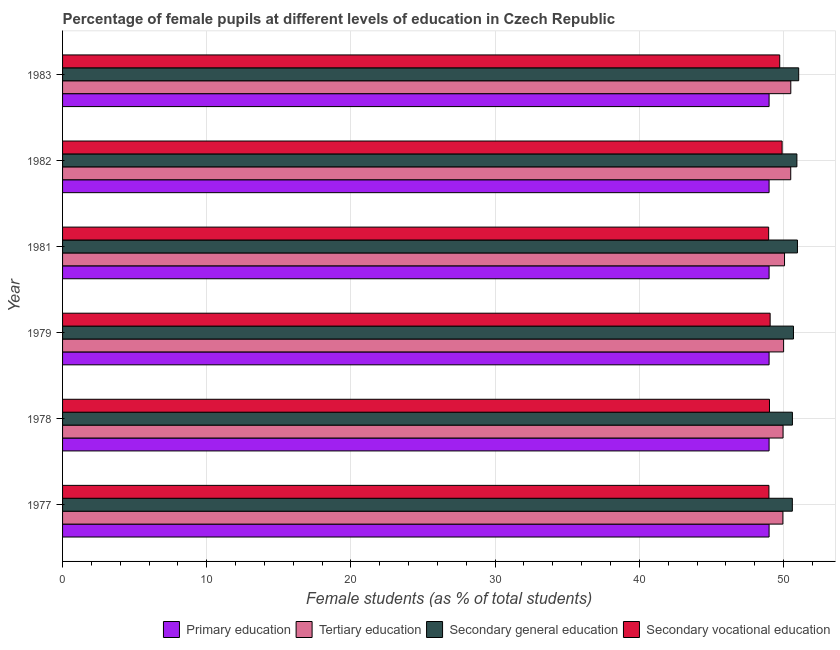How many different coloured bars are there?
Your response must be concise. 4. Are the number of bars on each tick of the Y-axis equal?
Keep it short and to the point. Yes. What is the percentage of female students in secondary education in 1978?
Give a very brief answer. 50.62. Across all years, what is the maximum percentage of female students in primary education?
Make the answer very short. 49. Across all years, what is the minimum percentage of female students in secondary vocational education?
Provide a succinct answer. 48.97. In which year was the percentage of female students in primary education minimum?
Ensure brevity in your answer.  1979. What is the total percentage of female students in tertiary education in the graph?
Ensure brevity in your answer.  301.01. What is the difference between the percentage of female students in tertiary education in 1979 and the percentage of female students in primary education in 1978?
Ensure brevity in your answer.  1.01. What is the average percentage of female students in secondary vocational education per year?
Ensure brevity in your answer.  49.28. In the year 1981, what is the difference between the percentage of female students in tertiary education and percentage of female students in primary education?
Offer a terse response. 1.07. In how many years, is the percentage of female students in secondary vocational education greater than 36 %?
Give a very brief answer. 6. What is the ratio of the percentage of female students in tertiary education in 1977 to that in 1983?
Make the answer very short. 0.99. What is the difference between the highest and the second highest percentage of female students in secondary education?
Your answer should be very brief. 0.09. What is the difference between the highest and the lowest percentage of female students in primary education?
Offer a terse response. 0. In how many years, is the percentage of female students in primary education greater than the average percentage of female students in primary education taken over all years?
Make the answer very short. 3. Is the sum of the percentage of female students in secondary vocational education in 1977 and 1981 greater than the maximum percentage of female students in tertiary education across all years?
Keep it short and to the point. Yes. What does the 2nd bar from the top in 1982 represents?
Give a very brief answer. Secondary general education. What does the 2nd bar from the bottom in 1977 represents?
Give a very brief answer. Tertiary education. How many years are there in the graph?
Offer a very short reply. 6. What is the difference between two consecutive major ticks on the X-axis?
Your answer should be very brief. 10. Does the graph contain any zero values?
Keep it short and to the point. No. Where does the legend appear in the graph?
Provide a short and direct response. Bottom right. What is the title of the graph?
Ensure brevity in your answer.  Percentage of female pupils at different levels of education in Czech Republic. What is the label or title of the X-axis?
Ensure brevity in your answer.  Female students (as % of total students). What is the Female students (as % of total students) of Primary education in 1977?
Give a very brief answer. 49. What is the Female students (as % of total students) in Tertiary education in 1977?
Provide a succinct answer. 49.96. What is the Female students (as % of total students) in Secondary general education in 1977?
Provide a succinct answer. 50.61. What is the Female students (as % of total students) in Secondary vocational education in 1977?
Make the answer very short. 48.99. What is the Female students (as % of total students) in Primary education in 1978?
Give a very brief answer. 49. What is the Female students (as % of total students) of Tertiary education in 1978?
Ensure brevity in your answer.  49.97. What is the Female students (as % of total students) in Secondary general education in 1978?
Provide a succinct answer. 50.62. What is the Female students (as % of total students) of Secondary vocational education in 1978?
Offer a terse response. 49.03. What is the Female students (as % of total students) of Primary education in 1979?
Provide a succinct answer. 49. What is the Female students (as % of total students) in Tertiary education in 1979?
Make the answer very short. 50.01. What is the Female students (as % of total students) of Secondary general education in 1979?
Your answer should be compact. 50.69. What is the Female students (as % of total students) of Secondary vocational education in 1979?
Keep it short and to the point. 49.07. What is the Female students (as % of total students) of Primary education in 1981?
Offer a very short reply. 49. What is the Female students (as % of total students) in Tertiary education in 1981?
Offer a terse response. 50.07. What is the Female students (as % of total students) in Secondary general education in 1981?
Your answer should be compact. 50.97. What is the Female students (as % of total students) in Secondary vocational education in 1981?
Offer a terse response. 48.97. What is the Female students (as % of total students) in Primary education in 1982?
Provide a succinct answer. 49. What is the Female students (as % of total students) in Tertiary education in 1982?
Provide a short and direct response. 50.5. What is the Female students (as % of total students) of Secondary general education in 1982?
Provide a short and direct response. 50.93. What is the Female students (as % of total students) in Secondary vocational education in 1982?
Your answer should be very brief. 49.9. What is the Female students (as % of total students) of Tertiary education in 1983?
Provide a succinct answer. 50.51. What is the Female students (as % of total students) of Secondary general education in 1983?
Make the answer very short. 51.05. What is the Female students (as % of total students) of Secondary vocational education in 1983?
Your response must be concise. 49.74. Across all years, what is the maximum Female students (as % of total students) in Primary education?
Your answer should be very brief. 49. Across all years, what is the maximum Female students (as % of total students) of Tertiary education?
Make the answer very short. 50.51. Across all years, what is the maximum Female students (as % of total students) in Secondary general education?
Provide a short and direct response. 51.05. Across all years, what is the maximum Female students (as % of total students) of Secondary vocational education?
Give a very brief answer. 49.9. Across all years, what is the minimum Female students (as % of total students) of Primary education?
Offer a very short reply. 49. Across all years, what is the minimum Female students (as % of total students) in Tertiary education?
Provide a succinct answer. 49.96. Across all years, what is the minimum Female students (as % of total students) of Secondary general education?
Ensure brevity in your answer.  50.61. Across all years, what is the minimum Female students (as % of total students) in Secondary vocational education?
Provide a short and direct response. 48.97. What is the total Female students (as % of total students) in Primary education in the graph?
Provide a short and direct response. 294. What is the total Female students (as % of total students) in Tertiary education in the graph?
Keep it short and to the point. 301.01. What is the total Female students (as % of total students) of Secondary general education in the graph?
Make the answer very short. 304.87. What is the total Female students (as % of total students) of Secondary vocational education in the graph?
Provide a succinct answer. 295.7. What is the difference between the Female students (as % of total students) of Primary education in 1977 and that in 1978?
Your response must be concise. 0. What is the difference between the Female students (as % of total students) of Tertiary education in 1977 and that in 1978?
Ensure brevity in your answer.  -0.01. What is the difference between the Female students (as % of total students) in Secondary general education in 1977 and that in 1978?
Keep it short and to the point. -0. What is the difference between the Female students (as % of total students) of Secondary vocational education in 1977 and that in 1978?
Offer a terse response. -0.04. What is the difference between the Female students (as % of total students) in Primary education in 1977 and that in 1979?
Your answer should be very brief. 0. What is the difference between the Female students (as % of total students) in Tertiary education in 1977 and that in 1979?
Keep it short and to the point. -0.05. What is the difference between the Female students (as % of total students) of Secondary general education in 1977 and that in 1979?
Your response must be concise. -0.08. What is the difference between the Female students (as % of total students) in Secondary vocational education in 1977 and that in 1979?
Offer a very short reply. -0.08. What is the difference between the Female students (as % of total students) in Primary education in 1977 and that in 1981?
Your answer should be compact. 0. What is the difference between the Female students (as % of total students) in Tertiary education in 1977 and that in 1981?
Your answer should be compact. -0.11. What is the difference between the Female students (as % of total students) in Secondary general education in 1977 and that in 1981?
Give a very brief answer. -0.35. What is the difference between the Female students (as % of total students) in Secondary vocational education in 1977 and that in 1981?
Offer a very short reply. 0.02. What is the difference between the Female students (as % of total students) of Primary education in 1977 and that in 1982?
Offer a terse response. -0. What is the difference between the Female students (as % of total students) of Tertiary education in 1977 and that in 1982?
Keep it short and to the point. -0.54. What is the difference between the Female students (as % of total students) in Secondary general education in 1977 and that in 1982?
Your answer should be compact. -0.32. What is the difference between the Female students (as % of total students) in Secondary vocational education in 1977 and that in 1982?
Keep it short and to the point. -0.91. What is the difference between the Female students (as % of total students) in Primary education in 1977 and that in 1983?
Provide a succinct answer. -0. What is the difference between the Female students (as % of total students) of Tertiary education in 1977 and that in 1983?
Provide a succinct answer. -0.55. What is the difference between the Female students (as % of total students) of Secondary general education in 1977 and that in 1983?
Keep it short and to the point. -0.44. What is the difference between the Female students (as % of total students) in Secondary vocational education in 1977 and that in 1983?
Give a very brief answer. -0.75. What is the difference between the Female students (as % of total students) in Tertiary education in 1978 and that in 1979?
Provide a short and direct response. -0.04. What is the difference between the Female students (as % of total students) in Secondary general education in 1978 and that in 1979?
Give a very brief answer. -0.07. What is the difference between the Female students (as % of total students) of Secondary vocational education in 1978 and that in 1979?
Your answer should be very brief. -0.05. What is the difference between the Female students (as % of total students) in Tertiary education in 1978 and that in 1981?
Your response must be concise. -0.1. What is the difference between the Female students (as % of total students) of Secondary general education in 1978 and that in 1981?
Offer a very short reply. -0.35. What is the difference between the Female students (as % of total students) of Secondary vocational education in 1978 and that in 1981?
Provide a short and direct response. 0.06. What is the difference between the Female students (as % of total students) in Primary education in 1978 and that in 1982?
Your answer should be compact. -0. What is the difference between the Female students (as % of total students) in Tertiary education in 1978 and that in 1982?
Provide a short and direct response. -0.53. What is the difference between the Female students (as % of total students) in Secondary general education in 1978 and that in 1982?
Ensure brevity in your answer.  -0.31. What is the difference between the Female students (as % of total students) in Secondary vocational education in 1978 and that in 1982?
Your answer should be very brief. -0.88. What is the difference between the Female students (as % of total students) of Primary education in 1978 and that in 1983?
Ensure brevity in your answer.  -0. What is the difference between the Female students (as % of total students) in Tertiary education in 1978 and that in 1983?
Keep it short and to the point. -0.54. What is the difference between the Female students (as % of total students) of Secondary general education in 1978 and that in 1983?
Your response must be concise. -0.43. What is the difference between the Female students (as % of total students) of Secondary vocational education in 1978 and that in 1983?
Give a very brief answer. -0.71. What is the difference between the Female students (as % of total students) in Primary education in 1979 and that in 1981?
Your answer should be very brief. -0. What is the difference between the Female students (as % of total students) in Tertiary education in 1979 and that in 1981?
Offer a terse response. -0.06. What is the difference between the Female students (as % of total students) in Secondary general education in 1979 and that in 1981?
Give a very brief answer. -0.28. What is the difference between the Female students (as % of total students) of Secondary vocational education in 1979 and that in 1981?
Your response must be concise. 0.1. What is the difference between the Female students (as % of total students) of Primary education in 1979 and that in 1982?
Your answer should be very brief. -0. What is the difference between the Female students (as % of total students) of Tertiary education in 1979 and that in 1982?
Provide a short and direct response. -0.49. What is the difference between the Female students (as % of total students) in Secondary general education in 1979 and that in 1982?
Make the answer very short. -0.24. What is the difference between the Female students (as % of total students) of Secondary vocational education in 1979 and that in 1982?
Offer a very short reply. -0.83. What is the difference between the Female students (as % of total students) of Primary education in 1979 and that in 1983?
Give a very brief answer. -0. What is the difference between the Female students (as % of total students) in Tertiary education in 1979 and that in 1983?
Ensure brevity in your answer.  -0.5. What is the difference between the Female students (as % of total students) of Secondary general education in 1979 and that in 1983?
Your answer should be very brief. -0.36. What is the difference between the Female students (as % of total students) of Secondary vocational education in 1979 and that in 1983?
Make the answer very short. -0.67. What is the difference between the Female students (as % of total students) of Primary education in 1981 and that in 1982?
Give a very brief answer. -0. What is the difference between the Female students (as % of total students) in Tertiary education in 1981 and that in 1982?
Keep it short and to the point. -0.43. What is the difference between the Female students (as % of total students) in Secondary general education in 1981 and that in 1982?
Provide a succinct answer. 0.04. What is the difference between the Female students (as % of total students) in Secondary vocational education in 1981 and that in 1982?
Provide a succinct answer. -0.93. What is the difference between the Female students (as % of total students) in Primary education in 1981 and that in 1983?
Offer a very short reply. -0. What is the difference between the Female students (as % of total students) of Tertiary education in 1981 and that in 1983?
Offer a very short reply. -0.43. What is the difference between the Female students (as % of total students) in Secondary general education in 1981 and that in 1983?
Keep it short and to the point. -0.09. What is the difference between the Female students (as % of total students) in Secondary vocational education in 1981 and that in 1983?
Keep it short and to the point. -0.77. What is the difference between the Female students (as % of total students) of Primary education in 1982 and that in 1983?
Ensure brevity in your answer.  0. What is the difference between the Female students (as % of total students) in Tertiary education in 1982 and that in 1983?
Ensure brevity in your answer.  -0. What is the difference between the Female students (as % of total students) of Secondary general education in 1982 and that in 1983?
Give a very brief answer. -0.12. What is the difference between the Female students (as % of total students) in Secondary vocational education in 1982 and that in 1983?
Offer a very short reply. 0.16. What is the difference between the Female students (as % of total students) in Primary education in 1977 and the Female students (as % of total students) in Tertiary education in 1978?
Keep it short and to the point. -0.97. What is the difference between the Female students (as % of total students) in Primary education in 1977 and the Female students (as % of total students) in Secondary general education in 1978?
Make the answer very short. -1.62. What is the difference between the Female students (as % of total students) of Primary education in 1977 and the Female students (as % of total students) of Secondary vocational education in 1978?
Your answer should be compact. -0.03. What is the difference between the Female students (as % of total students) of Tertiary education in 1977 and the Female students (as % of total students) of Secondary general education in 1978?
Provide a succinct answer. -0.66. What is the difference between the Female students (as % of total students) in Tertiary education in 1977 and the Female students (as % of total students) in Secondary vocational education in 1978?
Make the answer very short. 0.93. What is the difference between the Female students (as % of total students) in Secondary general education in 1977 and the Female students (as % of total students) in Secondary vocational education in 1978?
Offer a very short reply. 1.59. What is the difference between the Female students (as % of total students) of Primary education in 1977 and the Female students (as % of total students) of Tertiary education in 1979?
Your answer should be very brief. -1.01. What is the difference between the Female students (as % of total students) in Primary education in 1977 and the Female students (as % of total students) in Secondary general education in 1979?
Keep it short and to the point. -1.69. What is the difference between the Female students (as % of total students) of Primary education in 1977 and the Female students (as % of total students) of Secondary vocational education in 1979?
Ensure brevity in your answer.  -0.07. What is the difference between the Female students (as % of total students) of Tertiary education in 1977 and the Female students (as % of total students) of Secondary general education in 1979?
Give a very brief answer. -0.73. What is the difference between the Female students (as % of total students) of Tertiary education in 1977 and the Female students (as % of total students) of Secondary vocational education in 1979?
Make the answer very short. 0.88. What is the difference between the Female students (as % of total students) in Secondary general education in 1977 and the Female students (as % of total students) in Secondary vocational education in 1979?
Provide a short and direct response. 1.54. What is the difference between the Female students (as % of total students) in Primary education in 1977 and the Female students (as % of total students) in Tertiary education in 1981?
Keep it short and to the point. -1.07. What is the difference between the Female students (as % of total students) of Primary education in 1977 and the Female students (as % of total students) of Secondary general education in 1981?
Your answer should be very brief. -1.97. What is the difference between the Female students (as % of total students) in Primary education in 1977 and the Female students (as % of total students) in Secondary vocational education in 1981?
Give a very brief answer. 0.03. What is the difference between the Female students (as % of total students) in Tertiary education in 1977 and the Female students (as % of total students) in Secondary general education in 1981?
Give a very brief answer. -1.01. What is the difference between the Female students (as % of total students) of Tertiary education in 1977 and the Female students (as % of total students) of Secondary vocational education in 1981?
Offer a very short reply. 0.99. What is the difference between the Female students (as % of total students) of Secondary general education in 1977 and the Female students (as % of total students) of Secondary vocational education in 1981?
Offer a very short reply. 1.64. What is the difference between the Female students (as % of total students) of Primary education in 1977 and the Female students (as % of total students) of Tertiary education in 1982?
Your response must be concise. -1.5. What is the difference between the Female students (as % of total students) of Primary education in 1977 and the Female students (as % of total students) of Secondary general education in 1982?
Your answer should be very brief. -1.93. What is the difference between the Female students (as % of total students) in Primary education in 1977 and the Female students (as % of total students) in Secondary vocational education in 1982?
Your response must be concise. -0.9. What is the difference between the Female students (as % of total students) in Tertiary education in 1977 and the Female students (as % of total students) in Secondary general education in 1982?
Give a very brief answer. -0.97. What is the difference between the Female students (as % of total students) of Tertiary education in 1977 and the Female students (as % of total students) of Secondary vocational education in 1982?
Keep it short and to the point. 0.05. What is the difference between the Female students (as % of total students) in Secondary general education in 1977 and the Female students (as % of total students) in Secondary vocational education in 1982?
Keep it short and to the point. 0.71. What is the difference between the Female students (as % of total students) of Primary education in 1977 and the Female students (as % of total students) of Tertiary education in 1983?
Your answer should be compact. -1.51. What is the difference between the Female students (as % of total students) in Primary education in 1977 and the Female students (as % of total students) in Secondary general education in 1983?
Your answer should be very brief. -2.05. What is the difference between the Female students (as % of total students) in Primary education in 1977 and the Female students (as % of total students) in Secondary vocational education in 1983?
Ensure brevity in your answer.  -0.74. What is the difference between the Female students (as % of total students) in Tertiary education in 1977 and the Female students (as % of total students) in Secondary general education in 1983?
Give a very brief answer. -1.1. What is the difference between the Female students (as % of total students) in Tertiary education in 1977 and the Female students (as % of total students) in Secondary vocational education in 1983?
Offer a very short reply. 0.22. What is the difference between the Female students (as % of total students) of Secondary general education in 1977 and the Female students (as % of total students) of Secondary vocational education in 1983?
Keep it short and to the point. 0.87. What is the difference between the Female students (as % of total students) in Primary education in 1978 and the Female students (as % of total students) in Tertiary education in 1979?
Your response must be concise. -1.01. What is the difference between the Female students (as % of total students) of Primary education in 1978 and the Female students (as % of total students) of Secondary general education in 1979?
Make the answer very short. -1.69. What is the difference between the Female students (as % of total students) of Primary education in 1978 and the Female students (as % of total students) of Secondary vocational education in 1979?
Keep it short and to the point. -0.07. What is the difference between the Female students (as % of total students) of Tertiary education in 1978 and the Female students (as % of total students) of Secondary general education in 1979?
Make the answer very short. -0.72. What is the difference between the Female students (as % of total students) in Tertiary education in 1978 and the Female students (as % of total students) in Secondary vocational education in 1979?
Ensure brevity in your answer.  0.9. What is the difference between the Female students (as % of total students) in Secondary general education in 1978 and the Female students (as % of total students) in Secondary vocational education in 1979?
Provide a succinct answer. 1.55. What is the difference between the Female students (as % of total students) of Primary education in 1978 and the Female students (as % of total students) of Tertiary education in 1981?
Offer a terse response. -1.07. What is the difference between the Female students (as % of total students) of Primary education in 1978 and the Female students (as % of total students) of Secondary general education in 1981?
Ensure brevity in your answer.  -1.97. What is the difference between the Female students (as % of total students) of Primary education in 1978 and the Female students (as % of total students) of Secondary vocational education in 1981?
Your response must be concise. 0.03. What is the difference between the Female students (as % of total students) in Tertiary education in 1978 and the Female students (as % of total students) in Secondary general education in 1981?
Keep it short and to the point. -1. What is the difference between the Female students (as % of total students) of Tertiary education in 1978 and the Female students (as % of total students) of Secondary vocational education in 1981?
Your answer should be compact. 1. What is the difference between the Female students (as % of total students) in Secondary general education in 1978 and the Female students (as % of total students) in Secondary vocational education in 1981?
Provide a short and direct response. 1.65. What is the difference between the Female students (as % of total students) of Primary education in 1978 and the Female students (as % of total students) of Tertiary education in 1982?
Your response must be concise. -1.5. What is the difference between the Female students (as % of total students) of Primary education in 1978 and the Female students (as % of total students) of Secondary general education in 1982?
Ensure brevity in your answer.  -1.93. What is the difference between the Female students (as % of total students) of Primary education in 1978 and the Female students (as % of total students) of Secondary vocational education in 1982?
Provide a succinct answer. -0.9. What is the difference between the Female students (as % of total students) in Tertiary education in 1978 and the Female students (as % of total students) in Secondary general education in 1982?
Provide a short and direct response. -0.96. What is the difference between the Female students (as % of total students) of Tertiary education in 1978 and the Female students (as % of total students) of Secondary vocational education in 1982?
Your answer should be compact. 0.07. What is the difference between the Female students (as % of total students) in Secondary general education in 1978 and the Female students (as % of total students) in Secondary vocational education in 1982?
Provide a succinct answer. 0.72. What is the difference between the Female students (as % of total students) of Primary education in 1978 and the Female students (as % of total students) of Tertiary education in 1983?
Your response must be concise. -1.51. What is the difference between the Female students (as % of total students) in Primary education in 1978 and the Female students (as % of total students) in Secondary general education in 1983?
Ensure brevity in your answer.  -2.05. What is the difference between the Female students (as % of total students) in Primary education in 1978 and the Female students (as % of total students) in Secondary vocational education in 1983?
Your answer should be compact. -0.74. What is the difference between the Female students (as % of total students) of Tertiary education in 1978 and the Female students (as % of total students) of Secondary general education in 1983?
Make the answer very short. -1.08. What is the difference between the Female students (as % of total students) in Tertiary education in 1978 and the Female students (as % of total students) in Secondary vocational education in 1983?
Keep it short and to the point. 0.23. What is the difference between the Female students (as % of total students) of Secondary general education in 1978 and the Female students (as % of total students) of Secondary vocational education in 1983?
Make the answer very short. 0.88. What is the difference between the Female students (as % of total students) of Primary education in 1979 and the Female students (as % of total students) of Tertiary education in 1981?
Make the answer very short. -1.07. What is the difference between the Female students (as % of total students) in Primary education in 1979 and the Female students (as % of total students) in Secondary general education in 1981?
Give a very brief answer. -1.97. What is the difference between the Female students (as % of total students) in Primary education in 1979 and the Female students (as % of total students) in Secondary vocational education in 1981?
Your answer should be compact. 0.03. What is the difference between the Female students (as % of total students) in Tertiary education in 1979 and the Female students (as % of total students) in Secondary general education in 1981?
Give a very brief answer. -0.96. What is the difference between the Female students (as % of total students) in Tertiary education in 1979 and the Female students (as % of total students) in Secondary vocational education in 1981?
Ensure brevity in your answer.  1.04. What is the difference between the Female students (as % of total students) of Secondary general education in 1979 and the Female students (as % of total students) of Secondary vocational education in 1981?
Offer a terse response. 1.72. What is the difference between the Female students (as % of total students) in Primary education in 1979 and the Female students (as % of total students) in Tertiary education in 1982?
Ensure brevity in your answer.  -1.5. What is the difference between the Female students (as % of total students) in Primary education in 1979 and the Female students (as % of total students) in Secondary general education in 1982?
Provide a succinct answer. -1.93. What is the difference between the Female students (as % of total students) of Primary education in 1979 and the Female students (as % of total students) of Secondary vocational education in 1982?
Your answer should be compact. -0.9. What is the difference between the Female students (as % of total students) in Tertiary education in 1979 and the Female students (as % of total students) in Secondary general education in 1982?
Make the answer very short. -0.92. What is the difference between the Female students (as % of total students) of Tertiary education in 1979 and the Female students (as % of total students) of Secondary vocational education in 1982?
Give a very brief answer. 0.1. What is the difference between the Female students (as % of total students) in Secondary general education in 1979 and the Female students (as % of total students) in Secondary vocational education in 1982?
Provide a short and direct response. 0.79. What is the difference between the Female students (as % of total students) of Primary education in 1979 and the Female students (as % of total students) of Tertiary education in 1983?
Your response must be concise. -1.51. What is the difference between the Female students (as % of total students) of Primary education in 1979 and the Female students (as % of total students) of Secondary general education in 1983?
Your answer should be compact. -2.05. What is the difference between the Female students (as % of total students) of Primary education in 1979 and the Female students (as % of total students) of Secondary vocational education in 1983?
Make the answer very short. -0.74. What is the difference between the Female students (as % of total students) in Tertiary education in 1979 and the Female students (as % of total students) in Secondary general education in 1983?
Offer a very short reply. -1.05. What is the difference between the Female students (as % of total students) in Tertiary education in 1979 and the Female students (as % of total students) in Secondary vocational education in 1983?
Give a very brief answer. 0.27. What is the difference between the Female students (as % of total students) in Secondary general education in 1979 and the Female students (as % of total students) in Secondary vocational education in 1983?
Provide a succinct answer. 0.95. What is the difference between the Female students (as % of total students) of Primary education in 1981 and the Female students (as % of total students) of Tertiary education in 1982?
Offer a very short reply. -1.5. What is the difference between the Female students (as % of total students) in Primary education in 1981 and the Female students (as % of total students) in Secondary general education in 1982?
Give a very brief answer. -1.93. What is the difference between the Female students (as % of total students) in Primary education in 1981 and the Female students (as % of total students) in Secondary vocational education in 1982?
Offer a terse response. -0.9. What is the difference between the Female students (as % of total students) in Tertiary education in 1981 and the Female students (as % of total students) in Secondary general education in 1982?
Ensure brevity in your answer.  -0.86. What is the difference between the Female students (as % of total students) in Tertiary education in 1981 and the Female students (as % of total students) in Secondary vocational education in 1982?
Ensure brevity in your answer.  0.17. What is the difference between the Female students (as % of total students) of Secondary general education in 1981 and the Female students (as % of total students) of Secondary vocational education in 1982?
Offer a terse response. 1.06. What is the difference between the Female students (as % of total students) of Primary education in 1981 and the Female students (as % of total students) of Tertiary education in 1983?
Provide a short and direct response. -1.51. What is the difference between the Female students (as % of total students) in Primary education in 1981 and the Female students (as % of total students) in Secondary general education in 1983?
Offer a terse response. -2.05. What is the difference between the Female students (as % of total students) of Primary education in 1981 and the Female students (as % of total students) of Secondary vocational education in 1983?
Give a very brief answer. -0.74. What is the difference between the Female students (as % of total students) in Tertiary education in 1981 and the Female students (as % of total students) in Secondary general education in 1983?
Keep it short and to the point. -0.98. What is the difference between the Female students (as % of total students) in Tertiary education in 1981 and the Female students (as % of total students) in Secondary vocational education in 1983?
Keep it short and to the point. 0.33. What is the difference between the Female students (as % of total students) of Secondary general education in 1981 and the Female students (as % of total students) of Secondary vocational education in 1983?
Your answer should be compact. 1.23. What is the difference between the Female students (as % of total students) of Primary education in 1982 and the Female students (as % of total students) of Tertiary education in 1983?
Provide a short and direct response. -1.51. What is the difference between the Female students (as % of total students) of Primary education in 1982 and the Female students (as % of total students) of Secondary general education in 1983?
Provide a short and direct response. -2.05. What is the difference between the Female students (as % of total students) in Primary education in 1982 and the Female students (as % of total students) in Secondary vocational education in 1983?
Offer a terse response. -0.74. What is the difference between the Female students (as % of total students) in Tertiary education in 1982 and the Female students (as % of total students) in Secondary general education in 1983?
Provide a short and direct response. -0.55. What is the difference between the Female students (as % of total students) of Tertiary education in 1982 and the Female students (as % of total students) of Secondary vocational education in 1983?
Make the answer very short. 0.76. What is the difference between the Female students (as % of total students) of Secondary general education in 1982 and the Female students (as % of total students) of Secondary vocational education in 1983?
Make the answer very short. 1.19. What is the average Female students (as % of total students) of Primary education per year?
Your answer should be compact. 49. What is the average Female students (as % of total students) of Tertiary education per year?
Ensure brevity in your answer.  50.17. What is the average Female students (as % of total students) of Secondary general education per year?
Provide a short and direct response. 50.81. What is the average Female students (as % of total students) of Secondary vocational education per year?
Make the answer very short. 49.28. In the year 1977, what is the difference between the Female students (as % of total students) in Primary education and Female students (as % of total students) in Tertiary education?
Offer a very short reply. -0.96. In the year 1977, what is the difference between the Female students (as % of total students) of Primary education and Female students (as % of total students) of Secondary general education?
Your answer should be very brief. -1.61. In the year 1977, what is the difference between the Female students (as % of total students) in Primary education and Female students (as % of total students) in Secondary vocational education?
Provide a succinct answer. 0.01. In the year 1977, what is the difference between the Female students (as % of total students) of Tertiary education and Female students (as % of total students) of Secondary general education?
Keep it short and to the point. -0.66. In the year 1977, what is the difference between the Female students (as % of total students) in Tertiary education and Female students (as % of total students) in Secondary vocational education?
Your answer should be compact. 0.97. In the year 1977, what is the difference between the Female students (as % of total students) of Secondary general education and Female students (as % of total students) of Secondary vocational education?
Your answer should be very brief. 1.62. In the year 1978, what is the difference between the Female students (as % of total students) of Primary education and Female students (as % of total students) of Tertiary education?
Keep it short and to the point. -0.97. In the year 1978, what is the difference between the Female students (as % of total students) in Primary education and Female students (as % of total students) in Secondary general education?
Make the answer very short. -1.62. In the year 1978, what is the difference between the Female students (as % of total students) of Primary education and Female students (as % of total students) of Secondary vocational education?
Offer a terse response. -0.03. In the year 1978, what is the difference between the Female students (as % of total students) of Tertiary education and Female students (as % of total students) of Secondary general education?
Provide a succinct answer. -0.65. In the year 1978, what is the difference between the Female students (as % of total students) in Tertiary education and Female students (as % of total students) in Secondary vocational education?
Ensure brevity in your answer.  0.94. In the year 1978, what is the difference between the Female students (as % of total students) in Secondary general education and Female students (as % of total students) in Secondary vocational education?
Provide a succinct answer. 1.59. In the year 1979, what is the difference between the Female students (as % of total students) in Primary education and Female students (as % of total students) in Tertiary education?
Make the answer very short. -1.01. In the year 1979, what is the difference between the Female students (as % of total students) in Primary education and Female students (as % of total students) in Secondary general education?
Your response must be concise. -1.69. In the year 1979, what is the difference between the Female students (as % of total students) of Primary education and Female students (as % of total students) of Secondary vocational education?
Keep it short and to the point. -0.07. In the year 1979, what is the difference between the Female students (as % of total students) of Tertiary education and Female students (as % of total students) of Secondary general education?
Make the answer very short. -0.68. In the year 1979, what is the difference between the Female students (as % of total students) in Tertiary education and Female students (as % of total students) in Secondary vocational education?
Provide a short and direct response. 0.93. In the year 1979, what is the difference between the Female students (as % of total students) in Secondary general education and Female students (as % of total students) in Secondary vocational education?
Your answer should be very brief. 1.62. In the year 1981, what is the difference between the Female students (as % of total students) in Primary education and Female students (as % of total students) in Tertiary education?
Make the answer very short. -1.07. In the year 1981, what is the difference between the Female students (as % of total students) in Primary education and Female students (as % of total students) in Secondary general education?
Your response must be concise. -1.97. In the year 1981, what is the difference between the Female students (as % of total students) in Primary education and Female students (as % of total students) in Secondary vocational education?
Make the answer very short. 0.03. In the year 1981, what is the difference between the Female students (as % of total students) of Tertiary education and Female students (as % of total students) of Secondary general education?
Offer a terse response. -0.9. In the year 1981, what is the difference between the Female students (as % of total students) in Tertiary education and Female students (as % of total students) in Secondary vocational education?
Your answer should be very brief. 1.1. In the year 1981, what is the difference between the Female students (as % of total students) in Secondary general education and Female students (as % of total students) in Secondary vocational education?
Provide a short and direct response. 2. In the year 1982, what is the difference between the Female students (as % of total students) of Primary education and Female students (as % of total students) of Tertiary education?
Offer a terse response. -1.5. In the year 1982, what is the difference between the Female students (as % of total students) in Primary education and Female students (as % of total students) in Secondary general education?
Offer a terse response. -1.93. In the year 1982, what is the difference between the Female students (as % of total students) in Primary education and Female students (as % of total students) in Secondary vocational education?
Make the answer very short. -0.9. In the year 1982, what is the difference between the Female students (as % of total students) in Tertiary education and Female students (as % of total students) in Secondary general education?
Keep it short and to the point. -0.43. In the year 1982, what is the difference between the Female students (as % of total students) in Tertiary education and Female students (as % of total students) in Secondary vocational education?
Offer a very short reply. 0.6. In the year 1982, what is the difference between the Female students (as % of total students) of Secondary general education and Female students (as % of total students) of Secondary vocational education?
Give a very brief answer. 1.03. In the year 1983, what is the difference between the Female students (as % of total students) of Primary education and Female students (as % of total students) of Tertiary education?
Keep it short and to the point. -1.51. In the year 1983, what is the difference between the Female students (as % of total students) of Primary education and Female students (as % of total students) of Secondary general education?
Provide a succinct answer. -2.05. In the year 1983, what is the difference between the Female students (as % of total students) of Primary education and Female students (as % of total students) of Secondary vocational education?
Make the answer very short. -0.74. In the year 1983, what is the difference between the Female students (as % of total students) in Tertiary education and Female students (as % of total students) in Secondary general education?
Provide a succinct answer. -0.55. In the year 1983, what is the difference between the Female students (as % of total students) in Tertiary education and Female students (as % of total students) in Secondary vocational education?
Your answer should be compact. 0.77. In the year 1983, what is the difference between the Female students (as % of total students) of Secondary general education and Female students (as % of total students) of Secondary vocational education?
Keep it short and to the point. 1.31. What is the ratio of the Female students (as % of total students) of Primary education in 1977 to that in 1978?
Your answer should be compact. 1. What is the ratio of the Female students (as % of total students) in Secondary vocational education in 1977 to that in 1978?
Offer a terse response. 1. What is the ratio of the Female students (as % of total students) of Primary education in 1977 to that in 1979?
Provide a succinct answer. 1. What is the ratio of the Female students (as % of total students) in Tertiary education in 1977 to that in 1979?
Offer a terse response. 1. What is the ratio of the Female students (as % of total students) of Tertiary education in 1977 to that in 1981?
Provide a succinct answer. 1. What is the ratio of the Female students (as % of total students) of Secondary general education in 1977 to that in 1981?
Your response must be concise. 0.99. What is the ratio of the Female students (as % of total students) in Secondary vocational education in 1977 to that in 1981?
Your answer should be compact. 1. What is the ratio of the Female students (as % of total students) in Tertiary education in 1977 to that in 1982?
Provide a short and direct response. 0.99. What is the ratio of the Female students (as % of total students) of Secondary general education in 1977 to that in 1982?
Ensure brevity in your answer.  0.99. What is the ratio of the Female students (as % of total students) of Secondary vocational education in 1977 to that in 1982?
Your response must be concise. 0.98. What is the ratio of the Female students (as % of total students) of Tertiary education in 1977 to that in 1983?
Make the answer very short. 0.99. What is the ratio of the Female students (as % of total students) in Secondary vocational education in 1977 to that in 1983?
Provide a short and direct response. 0.98. What is the ratio of the Female students (as % of total students) of Tertiary education in 1978 to that in 1979?
Your answer should be compact. 1. What is the ratio of the Female students (as % of total students) in Secondary vocational education in 1978 to that in 1979?
Provide a short and direct response. 1. What is the ratio of the Female students (as % of total students) of Tertiary education in 1978 to that in 1981?
Provide a short and direct response. 1. What is the ratio of the Female students (as % of total students) in Secondary vocational education in 1978 to that in 1981?
Keep it short and to the point. 1. What is the ratio of the Female students (as % of total students) of Secondary vocational education in 1978 to that in 1982?
Make the answer very short. 0.98. What is the ratio of the Female students (as % of total students) in Primary education in 1978 to that in 1983?
Offer a terse response. 1. What is the ratio of the Female students (as % of total students) of Secondary general education in 1978 to that in 1983?
Your response must be concise. 0.99. What is the ratio of the Female students (as % of total students) in Secondary vocational education in 1978 to that in 1983?
Your response must be concise. 0.99. What is the ratio of the Female students (as % of total students) in Secondary general education in 1979 to that in 1981?
Offer a very short reply. 0.99. What is the ratio of the Female students (as % of total students) in Secondary vocational education in 1979 to that in 1981?
Keep it short and to the point. 1. What is the ratio of the Female students (as % of total students) of Tertiary education in 1979 to that in 1982?
Offer a very short reply. 0.99. What is the ratio of the Female students (as % of total students) in Secondary general education in 1979 to that in 1982?
Offer a terse response. 1. What is the ratio of the Female students (as % of total students) of Secondary vocational education in 1979 to that in 1982?
Provide a short and direct response. 0.98. What is the ratio of the Female students (as % of total students) of Tertiary education in 1979 to that in 1983?
Keep it short and to the point. 0.99. What is the ratio of the Female students (as % of total students) in Secondary general education in 1979 to that in 1983?
Make the answer very short. 0.99. What is the ratio of the Female students (as % of total students) in Secondary vocational education in 1979 to that in 1983?
Make the answer very short. 0.99. What is the ratio of the Female students (as % of total students) in Secondary vocational education in 1981 to that in 1982?
Your answer should be compact. 0.98. What is the ratio of the Female students (as % of total students) of Tertiary education in 1981 to that in 1983?
Provide a succinct answer. 0.99. What is the ratio of the Female students (as % of total students) in Secondary vocational education in 1981 to that in 1983?
Your answer should be very brief. 0.98. What is the difference between the highest and the second highest Female students (as % of total students) in Primary education?
Your answer should be very brief. 0. What is the difference between the highest and the second highest Female students (as % of total students) of Tertiary education?
Provide a succinct answer. 0. What is the difference between the highest and the second highest Female students (as % of total students) in Secondary general education?
Your answer should be very brief. 0.09. What is the difference between the highest and the second highest Female students (as % of total students) in Secondary vocational education?
Your response must be concise. 0.16. What is the difference between the highest and the lowest Female students (as % of total students) in Tertiary education?
Give a very brief answer. 0.55. What is the difference between the highest and the lowest Female students (as % of total students) of Secondary general education?
Ensure brevity in your answer.  0.44. What is the difference between the highest and the lowest Female students (as % of total students) in Secondary vocational education?
Your answer should be very brief. 0.93. 